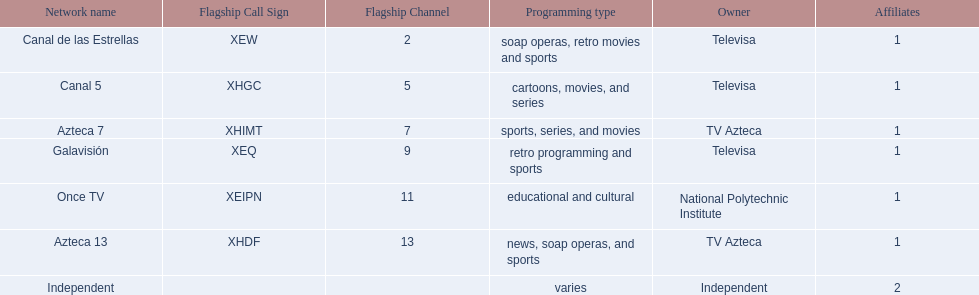What stations show sports? Soap operas, retro movies and sports, retro programming and sports, news, soap operas, and sports. What of these is not affiliated with televisa? Azteca 7. 